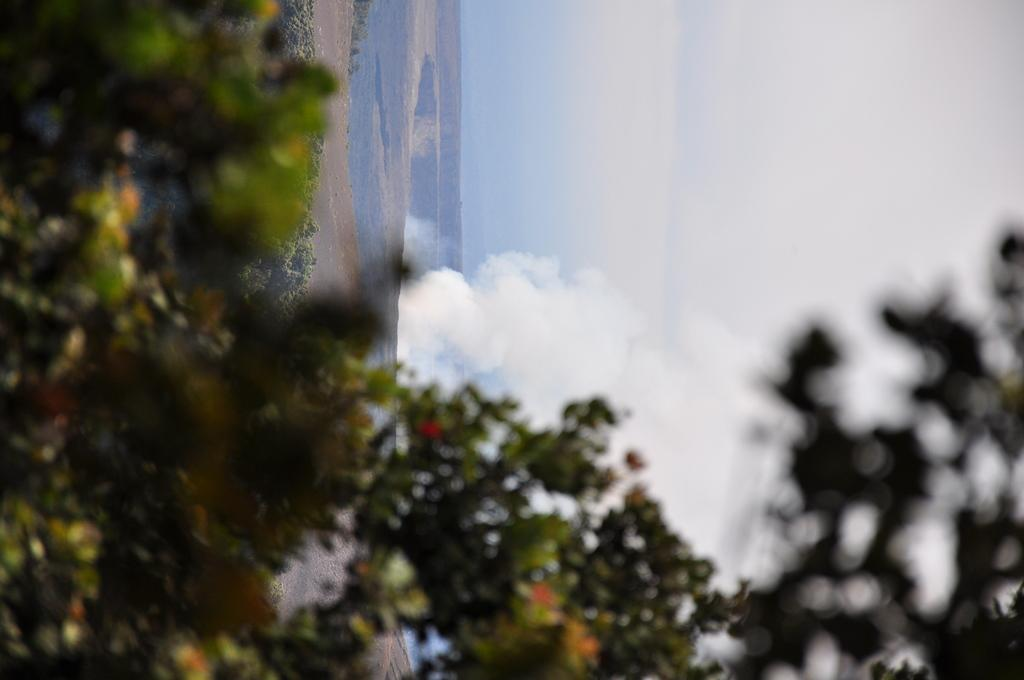What type of vegetation is present in the front of the image? There are trees in the front of the image. What can be seen coming out of a hole in the image? Smoke is coming out of a hole in the image. What is visible in the background of the image? The sky is visible in the background of the image. What type of dress is the doll wearing in the image? There is no doll present in the image, so it is not possible to answer that question. How many passengers are visible in the image? There is no reference to passengers in the image, so it is not possible to determine their number. 